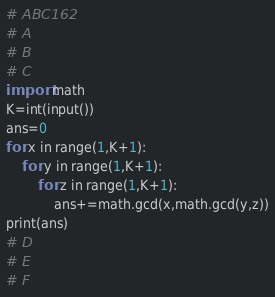<code> <loc_0><loc_0><loc_500><loc_500><_Python_># ABC162
# A
# B
# C
import math
K=int(input())
ans=0
for x in range(1,K+1):
    for y in range(1,K+1):
        for z in range(1,K+1):
            ans+=math.gcd(x,math.gcd(y,z))
print(ans)
# D
# E
# F
</code> 